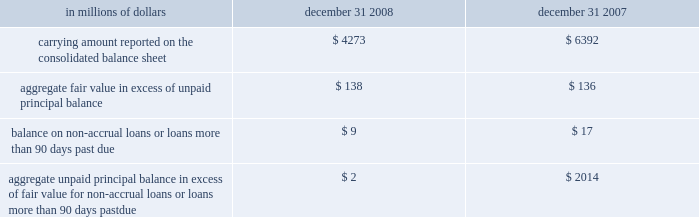The company has elected the fair-value option where the interest-rate risk of such liabilities is economically hedged with derivative contracts or the proceeds are used to purchase financial assets that will also be accounted for at fair value through earnings .
The election has been made to mitigate accounting mismatches and to achieve operational simplifications .
These positions are reported in short-term borrowings and long-term debt on the company 2019s consolidated balance sheet .
The majority of these non-structured liabilities are a result of the company 2019s election of the fair-value option for liabilities associated with the citi-advised structured investment vehicles ( sivs ) , which were consolidated during the fourth quarter of 2007 .
The change in fair values of the sivs 2019 liabilities reported in earnings was $ 2.6 billion for the year ended december 31 , 2008 .
For these non-structured liabilities the aggregate fair value is $ 263 million lower than the aggregate unpaid principal balance as of december 31 , 2008 .
For all other non-structured liabilities classified as long-term debt for which the fair-value option has been elected , the aggregate unpaid principal balance exceeds the aggregate fair value of such instruments by $ 97 million as of december 31 , 2008 while the aggregate fair value exceeded the aggregate unpaid principal by $ 112 million as of december 31 , 2007 .
The change in fair value of these non-structured liabilities reported a gain of $ 1.2 billion for the year ended december 31 , 2008 .
The change in fair value for these non-structured liabilities is reported in principal transactions in the company 2019s consolidated statement of income .
Related interest expense continues to be measured based on the contractual interest rates and reported as such in the consolidated income statement .
Certain mortgage loans citigroup has elected the fair-value option for certain purchased and originated prime fixed-rate and conforming adjustable-rate first mortgage loans held-for- sale .
These loans are intended for sale or securitization and are hedged with derivative instruments .
The company has elected the fair-value option to mitigate accounting mismatches in cases where hedge accounting is complex and to achieve operational simplifications .
The fair-value option was not elected for loans held-for-investment , as those loans are not hedged with derivative instruments .
This election was effective for applicable instruments originated or purchased on or after september 1 , 2007 .
The table provides information about certain mortgage loans carried at fair value : in millions of dollars december 31 , december 31 , carrying amount reported on the consolidated balance sheet $ 4273 $ 6392 aggregate fair value in excess of unpaid principal balance $ 138 $ 136 balance on non-accrual loans or loans more than 90 days past due $ 9 $ 17 aggregate unpaid principal balance in excess of fair value for non-accrual loans or loans more than 90 days past due $ 2 $ 2014 the changes in fair values of these mortgage loans is reported in other revenue in the company 2019s consolidated statement of income .
The changes in fair value during the year ended december 31 , 2008 due to instrument- specific credit risk resulted in a $ 32 million loss .
The change in fair value during 2007 due to instrument-specific credit risk was immaterial .
Related interest income continues to be measured based on the contractual interest rates and reported as such in the consolidated income statement .
Items selected for fair-value accounting in accordance with sfas 155 and sfas 156 certain hybrid financial instruments the company has elected to apply fair-value accounting under sfas 155 for certain hybrid financial assets and liabilities whose performance is linked to risks other than interest rate , foreign exchange or inflation ( e.g. , equity , credit or commodity risks ) .
In addition , the company has elected fair-value accounting under sfas 155 for residual interests retained from securitizing certain financial assets .
The company has elected fair-value accounting for these instruments because these exposures are considered to be trading-related positions and , therefore , are managed on a fair-value basis .
In addition , the accounting for these instruments is simplified under a fair-value approach as it eliminates the complicated operational requirements of bifurcating the embedded derivatives from the host contracts and accounting for each separately .
The hybrid financial instruments are classified as trading account assets , loans , deposits , trading account liabilities ( for prepaid derivatives ) , short-term borrowings or long-term debt on the company 2019s consolidated balance sheet according to their legal form , while residual interests in certain securitizations are classified as trading account assets .
For hybrid financial instruments for which fair-value accounting has been elected under sfas 155 and that are classified as long-term debt , the aggregate unpaid principal exceeds the aggregate fair value by $ 1.9 billion as of december 31 , 2008 , while the aggregate fair value exceeds the aggregate unpaid principal balance by $ 460 million as of december 31 , 2007 .
The difference for those instruments classified as loans is immaterial .
Changes in fair value for hybrid financial instruments , which in most cases includes a component for accrued interest , are recorded in principal transactions in the company 2019s consolidated statement of income .
Interest accruals for certain hybrid instruments classified as trading assets are recorded separately from the change in fair value as interest revenue in the company 2019s consolidated statement of income .
Mortgage servicing rights the company accounts for mortgage servicing rights ( msrs ) at fair value in accordance with sfas 156 .
Fair value for msrs is determined using an option-adjusted spread valuation approach .
This approach consists of projecting servicing cash flows under multiple interest-rate scenarios and discounting these cash flows using risk-adjusted rates .
The model assumptions used in the valuation of msrs include mortgage prepayment speeds and discount rates .
The fair value of msrs is primarily affected by changes in prepayments that result from shifts in mortgage interest rates .
In managing this risk , the company hedges a significant portion of the values of its msrs through the use of interest-rate derivative contracts , forward- purchase commitments of mortgage-backed securities , and purchased securities classified as trading .
See note 23 on page 175 for further discussions regarding the accounting and reporting of msrs .
These msrs , which totaled $ 5.7 billion and $ 8.4 billion as of december 31 , 2008 and december 31 , 2007 , respectively , are classified as mortgage servicing rights on citigroup 2019s consolidated balance sheet .
Changes in fair value of msrs are recorded in commissions and fees in the company 2019s consolidated statement of income. .
The company has elected the fair-value option where the interest-rate risk of such liabilities is economically hedged with derivative contracts or the proceeds are used to purchase financial assets that will also be accounted for at fair value through earnings .
The election has been made to mitigate accounting mismatches and to achieve operational simplifications .
These positions are reported in short-term borrowings and long-term debt on the company 2019s consolidated balance sheet .
The majority of these non-structured liabilities are a result of the company 2019s election of the fair-value option for liabilities associated with the citi-advised structured investment vehicles ( sivs ) , which were consolidated during the fourth quarter of 2007 .
The change in fair values of the sivs 2019 liabilities reported in earnings was $ 2.6 billion for the year ended december 31 , 2008 .
For these non-structured liabilities the aggregate fair value is $ 263 million lower than the aggregate unpaid principal balance as of december 31 , 2008 .
For all other non-structured liabilities classified as long-term debt for which the fair-value option has been elected , the aggregate unpaid principal balance exceeds the aggregate fair value of such instruments by $ 97 million as of december 31 , 2008 while the aggregate fair value exceeded the aggregate unpaid principal by $ 112 million as of december 31 , 2007 .
The change in fair value of these non-structured liabilities reported a gain of $ 1.2 billion for the year ended december 31 , 2008 .
The change in fair value for these non-structured liabilities is reported in principal transactions in the company 2019s consolidated statement of income .
Related interest expense continues to be measured based on the contractual interest rates and reported as such in the consolidated income statement .
Certain mortgage loans citigroup has elected the fair-value option for certain purchased and originated prime fixed-rate and conforming adjustable-rate first mortgage loans held-for- sale .
These loans are intended for sale or securitization and are hedged with derivative instruments .
The company has elected the fair-value option to mitigate accounting mismatches in cases where hedge accounting is complex and to achieve operational simplifications .
The fair-value option was not elected for loans held-for-investment , as those loans are not hedged with derivative instruments .
This election was effective for applicable instruments originated or purchased on or after september 1 , 2007 .
The following table provides information about certain mortgage loans carried at fair value : in millions of dollars december 31 , december 31 , carrying amount reported on the consolidated balance sheet $ 4273 $ 6392 aggregate fair value in excess of unpaid principal balance $ 138 $ 136 balance on non-accrual loans or loans more than 90 days past due $ 9 $ 17 aggregate unpaid principal balance in excess of fair value for non-accrual loans or loans more than 90 days past due $ 2 $ 2014 the changes in fair values of these mortgage loans is reported in other revenue in the company 2019s consolidated statement of income .
The changes in fair value during the year ended december 31 , 2008 due to instrument- specific credit risk resulted in a $ 32 million loss .
The change in fair value during 2007 due to instrument-specific credit risk was immaterial .
Related interest income continues to be measured based on the contractual interest rates and reported as such in the consolidated income statement .
Items selected for fair-value accounting in accordance with sfas 155 and sfas 156 certain hybrid financial instruments the company has elected to apply fair-value accounting under sfas 155 for certain hybrid financial assets and liabilities whose performance is linked to risks other than interest rate , foreign exchange or inflation ( e.g. , equity , credit or commodity risks ) .
In addition , the company has elected fair-value accounting under sfas 155 for residual interests retained from securitizing certain financial assets .
The company has elected fair-value accounting for these instruments because these exposures are considered to be trading-related positions and , therefore , are managed on a fair-value basis .
In addition , the accounting for these instruments is simplified under a fair-value approach as it eliminates the complicated operational requirements of bifurcating the embedded derivatives from the host contracts and accounting for each separately .
The hybrid financial instruments are classified as trading account assets , loans , deposits , trading account liabilities ( for prepaid derivatives ) , short-term borrowings or long-term debt on the company 2019s consolidated balance sheet according to their legal form , while residual interests in certain securitizations are classified as trading account assets .
For hybrid financial instruments for which fair-value accounting has been elected under sfas 155 and that are classified as long-term debt , the aggregate unpaid principal exceeds the aggregate fair value by $ 1.9 billion as of december 31 , 2008 , while the aggregate fair value exceeds the aggregate unpaid principal balance by $ 460 million as of december 31 , 2007 .
The difference for those instruments classified as loans is immaterial .
Changes in fair value for hybrid financial instruments , which in most cases includes a component for accrued interest , are recorded in principal transactions in the company 2019s consolidated statement of income .
Interest accruals for certain hybrid instruments classified as trading assets are recorded separately from the change in fair value as interest revenue in the company 2019s consolidated statement of income .
Mortgage servicing rights the company accounts for mortgage servicing rights ( msrs ) at fair value in accordance with sfas 156 .
Fair value for msrs is determined using an option-adjusted spread valuation approach .
This approach consists of projecting servicing cash flows under multiple interest-rate scenarios and discounting these cash flows using risk-adjusted rates .
The model assumptions used in the valuation of msrs include mortgage prepayment speeds and discount rates .
The fair value of msrs is primarily affected by changes in prepayments that result from shifts in mortgage interest rates .
In managing this risk , the company hedges a significant portion of the values of its msrs through the use of interest-rate derivative contracts , forward- purchase commitments of mortgage-backed securities , and purchased securities classified as trading .
See note 23 on page 175 for further discussions regarding the accounting and reporting of msrs .
These msrs , which totaled $ 5.7 billion and $ 8.4 billion as of december 31 , 2008 and december 31 , 2007 , respectively , are classified as mortgage servicing rights on citigroup 2019s consolidated balance sheet .
Changes in fair value of msrs are recorded in commissions and fees in the company 2019s consolidated statement of income. .
What was the percentage change in the carrying amount reported on the consolidated balance sheet from 2007 to 2008? 
Computations: ((4273 - 6392) / 6392)
Answer: -0.33151. 